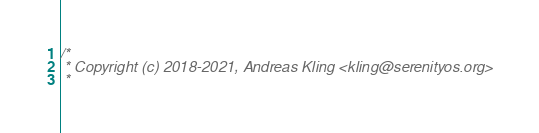Convert code to text. <code><loc_0><loc_0><loc_500><loc_500><_C++_>/*
 * Copyright (c) 2018-2021, Andreas Kling <kling@serenityos.org>
 *</code> 